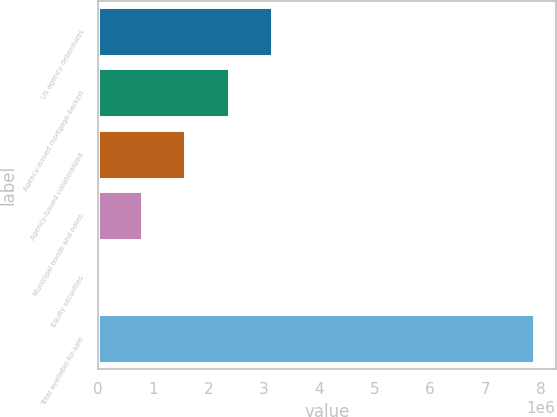<chart> <loc_0><loc_0><loc_500><loc_500><bar_chart><fcel>US agency debentures<fcel>Agency-issued mortgage-backed<fcel>Agency-issued collateralized<fcel>Municipal bonds and notes<fcel>Equity securities<fcel>Total available-for-sale<nl><fcel>3.15135e+06<fcel>2.3636e+06<fcel>1.57585e+06<fcel>788106<fcel>358<fcel>7.87784e+06<nl></chart> 